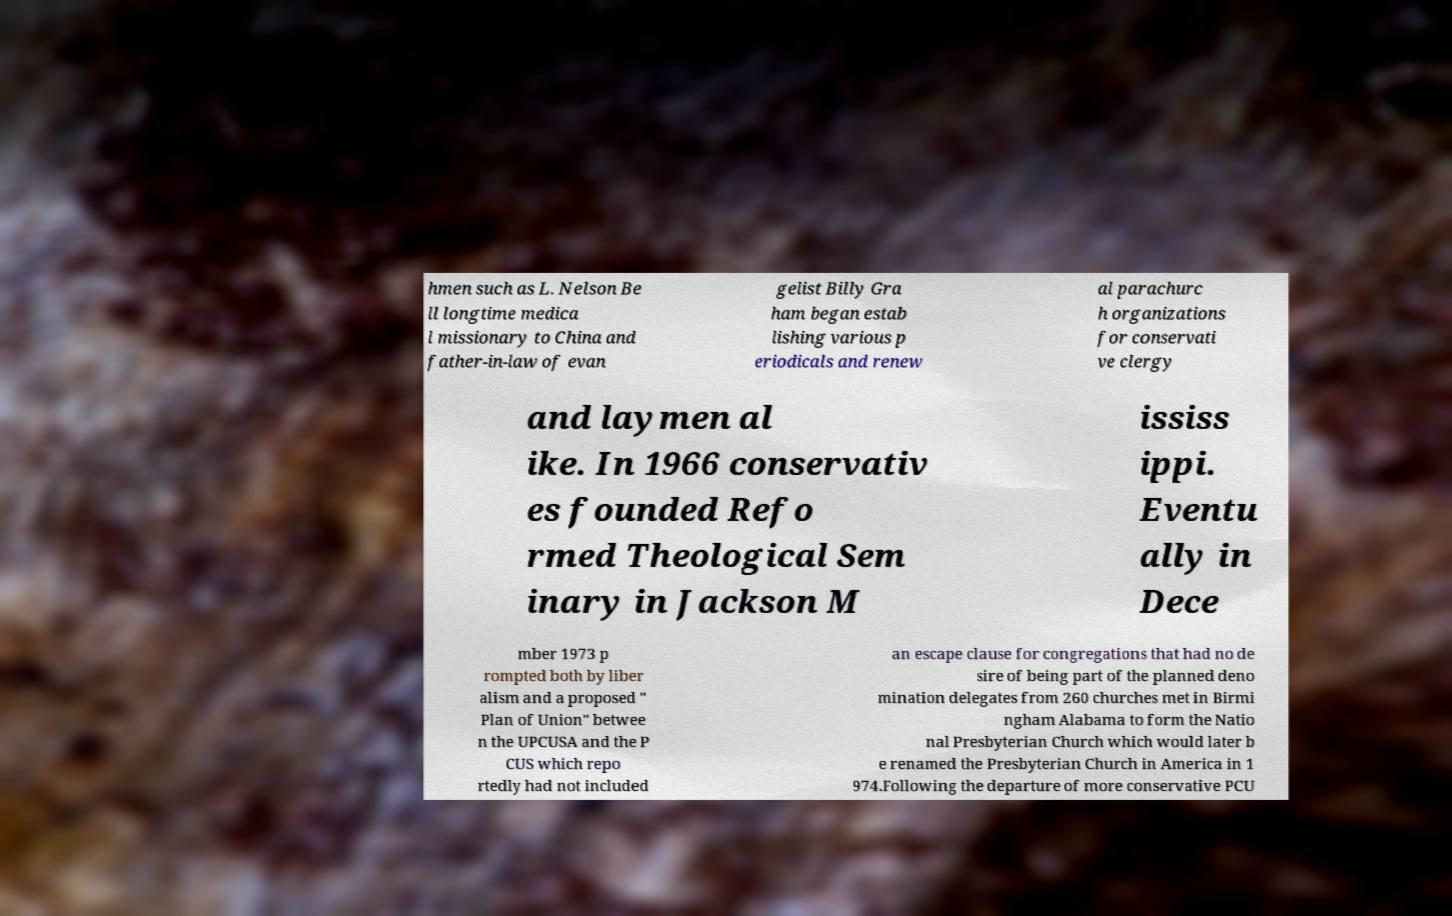For documentation purposes, I need the text within this image transcribed. Could you provide that? hmen such as L. Nelson Be ll longtime medica l missionary to China and father-in-law of evan gelist Billy Gra ham began estab lishing various p eriodicals and renew al parachurc h organizations for conservati ve clergy and laymen al ike. In 1966 conservativ es founded Refo rmed Theological Sem inary in Jackson M ississ ippi. Eventu ally in Dece mber 1973 p rompted both by liber alism and a proposed " Plan of Union" betwee n the UPCUSA and the P CUS which repo rtedly had not included an escape clause for congregations that had no de sire of being part of the planned deno mination delegates from 260 churches met in Birmi ngham Alabama to form the Natio nal Presbyterian Church which would later b e renamed the Presbyterian Church in America in 1 974.Following the departure of more conservative PCU 